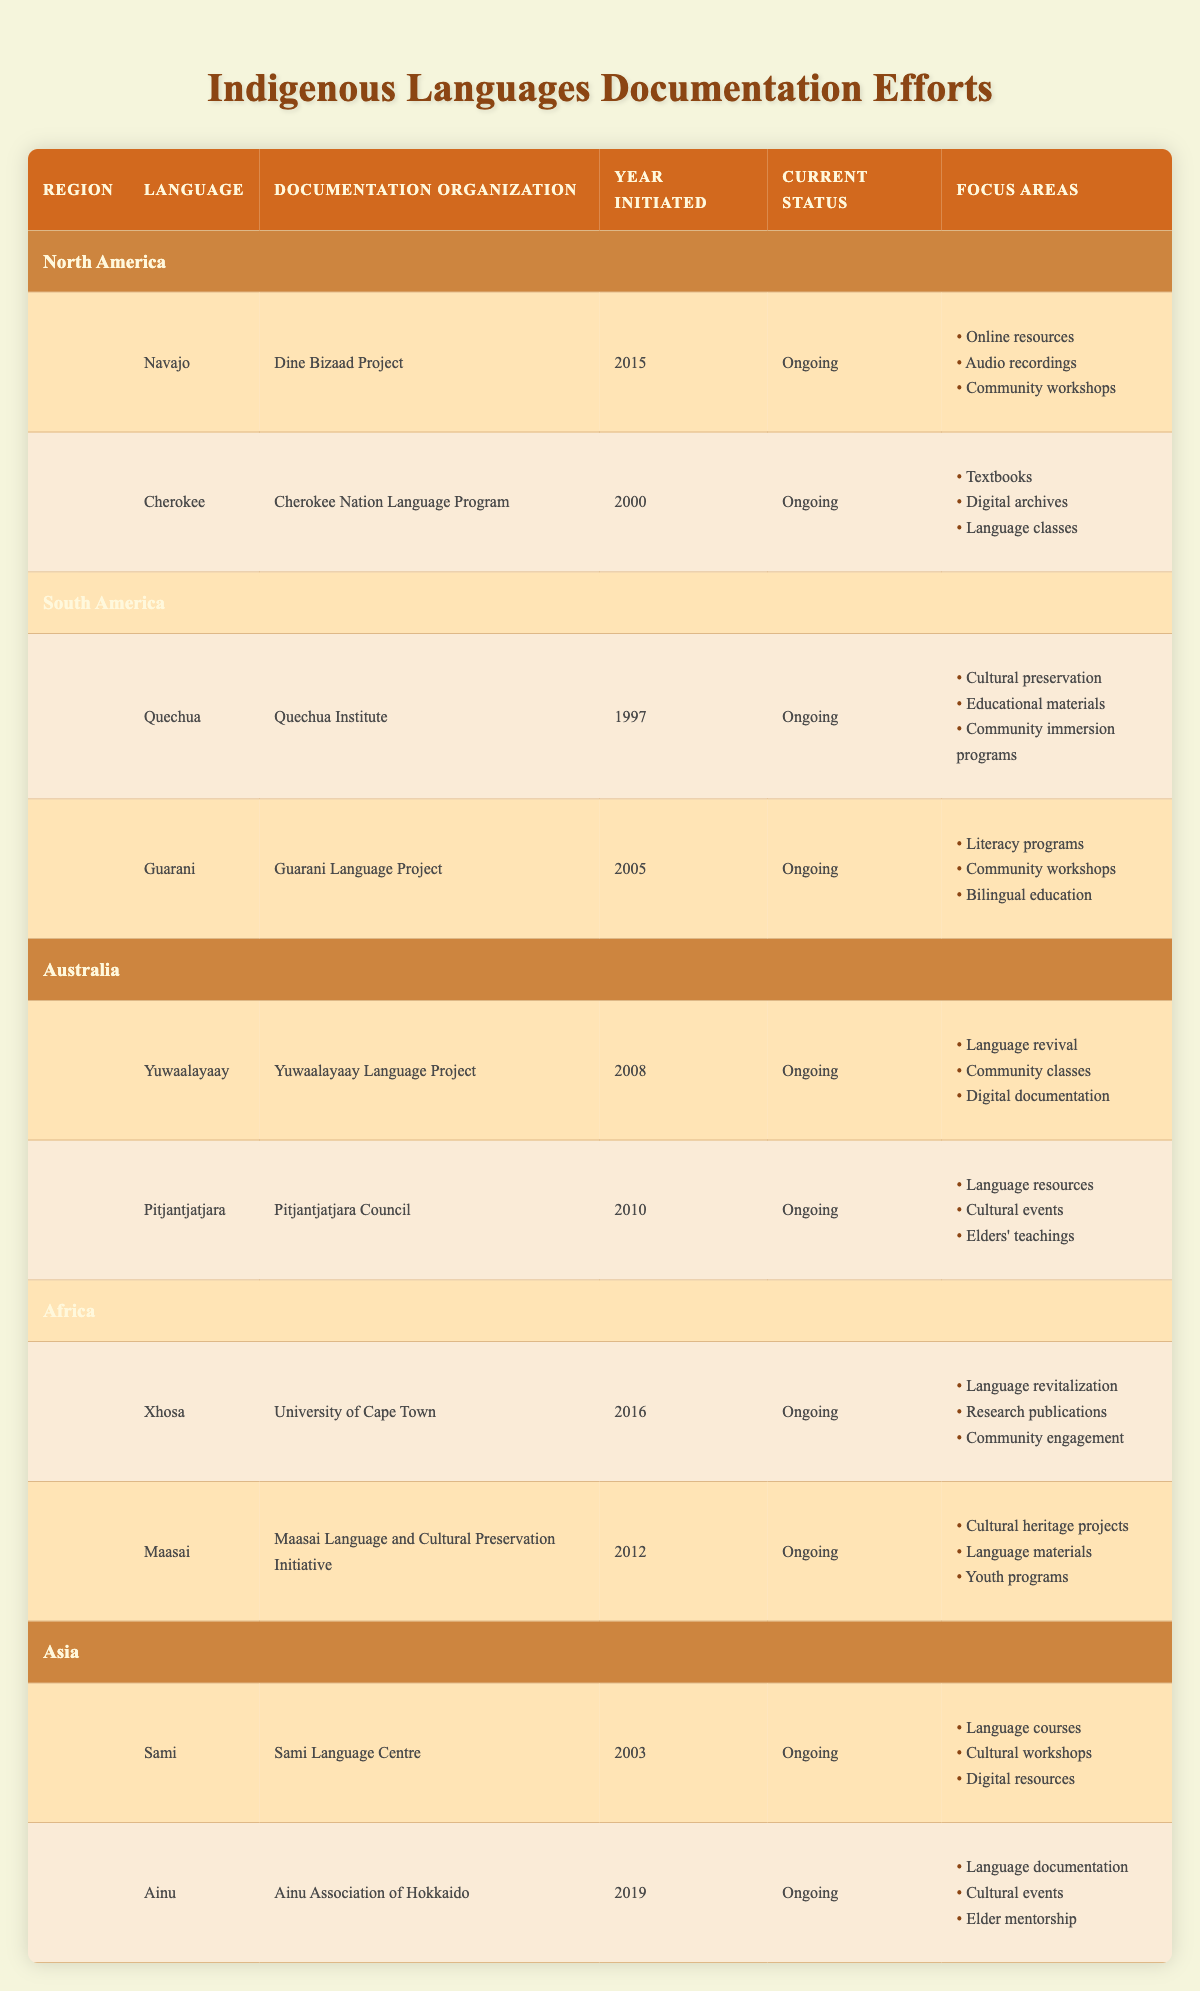What is the documentation organization for the Navajo language? The table lists "Dine Bizaad Project" as the documentation organization for the Navajo language under the North America region.
Answer: Dine Bizaad Project How many languages are documented under the South America region? The table shows that there are two languages documented under the South America region: Quechua and Guarani.
Answer: 2 Which language was initiated in 2010 for documentation efforts? By checking the year initiated for each language, Pitjantjatjara is the language listed with a year initiated of 2010 in the Australia region.
Answer: Pitjantjatjara Is the documentation of the Sami language ongoing? The table states that the current status for the Sami language is marked as "Ongoing."
Answer: Yes What are the focus areas for the Guarani language documentation? The focus areas for Guarani include literacy programs, community workshops, and bilingual education, as listed in the South America region.
Answer: Literacy programs, community workshops, bilingual education Which region has the language with the earliest year of documentation initiation? When comparing years of initiation, Quechua is initiated in 1997, earlier than any other language listed in the table from different regions.
Answer: South America How many languages are documented in total across all regions? By counting all the languages listed, we find 10 languages total (2 in North America, 2 in South America, 2 in Australia, 2 in Africa, and 2 in Asia).
Answer: 10 Which languages have a focus on community workshops? The table indicates that Navajo, Guarani, and Pitjantjatjara all have community workshops listed as focus areas for their documentation efforts.
Answer: Navajo, Guarani, Pitjantjatjara Which region has the most recent initiation year for its documented language? By examining the years, we see that Ainu in Asia has the most recent year of initiation, 2019, across all regions.
Answer: Asia Are there any language documentation projects focused on both cultural preservation and educational materials? The table shows that the Quechua language documentation project includes both cultural preservation and educational materials as focus areas.
Answer: Yes 